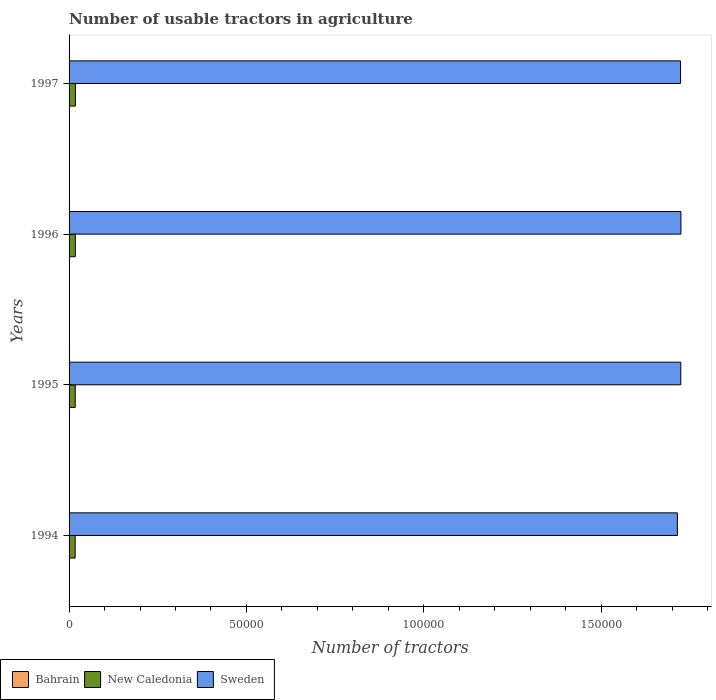How many bars are there on the 3rd tick from the top?
Make the answer very short. 3. How many bars are there on the 2nd tick from the bottom?
Your answer should be very brief. 3. In how many cases, is the number of bars for a given year not equal to the number of legend labels?
Offer a terse response. 0. Across all years, what is the maximum number of usable tractors in agriculture in Sweden?
Give a very brief answer. 1.72e+05. Across all years, what is the minimum number of usable tractors in agriculture in Sweden?
Ensure brevity in your answer.  1.72e+05. What is the difference between the number of usable tractors in agriculture in New Caledonia in 1996 and the number of usable tractors in agriculture in Sweden in 1995?
Your answer should be compact. -1.71e+05. What is the average number of usable tractors in agriculture in Sweden per year?
Provide a succinct answer. 1.72e+05. In the year 1996, what is the difference between the number of usable tractors in agriculture in Sweden and number of usable tractors in agriculture in Bahrain?
Offer a very short reply. 1.72e+05. In how many years, is the number of usable tractors in agriculture in New Caledonia greater than 110000 ?
Your answer should be very brief. 0. What is the ratio of the number of usable tractors in agriculture in New Caledonia in 1994 to that in 1997?
Offer a very short reply. 0.96. Is the number of usable tractors in agriculture in Sweden in 1995 less than that in 1996?
Provide a succinct answer. Yes. Is the difference between the number of usable tractors in agriculture in Sweden in 1995 and 1997 greater than the difference between the number of usable tractors in agriculture in Bahrain in 1995 and 1997?
Your answer should be very brief. Yes. What is the difference between the highest and the second highest number of usable tractors in agriculture in Sweden?
Give a very brief answer. 30. In how many years, is the number of usable tractors in agriculture in Bahrain greater than the average number of usable tractors in agriculture in Bahrain taken over all years?
Provide a succinct answer. 2. Is the sum of the number of usable tractors in agriculture in New Caledonia in 1994 and 1995 greater than the maximum number of usable tractors in agriculture in Bahrain across all years?
Your answer should be compact. Yes. What does the 2nd bar from the top in 1994 represents?
Keep it short and to the point. New Caledonia. What does the 2nd bar from the bottom in 1997 represents?
Your answer should be very brief. New Caledonia. Is it the case that in every year, the sum of the number of usable tractors in agriculture in Bahrain and number of usable tractors in agriculture in Sweden is greater than the number of usable tractors in agriculture in New Caledonia?
Ensure brevity in your answer.  Yes. How many bars are there?
Provide a short and direct response. 12. How many years are there in the graph?
Make the answer very short. 4. Does the graph contain any zero values?
Make the answer very short. No. Does the graph contain grids?
Your answer should be compact. No. How many legend labels are there?
Make the answer very short. 3. What is the title of the graph?
Provide a succinct answer. Number of usable tractors in agriculture. What is the label or title of the X-axis?
Keep it short and to the point. Number of tractors. What is the label or title of the Y-axis?
Offer a very short reply. Years. What is the Number of tractors in New Caledonia in 1994?
Give a very brief answer. 1710. What is the Number of tractors in Sweden in 1994?
Offer a terse response. 1.72e+05. What is the Number of tractors of Bahrain in 1995?
Offer a terse response. 14. What is the Number of tractors of New Caledonia in 1995?
Provide a short and direct response. 1735. What is the Number of tractors in Sweden in 1995?
Your answer should be very brief. 1.72e+05. What is the Number of tractors of Bahrain in 1996?
Give a very brief answer. 12. What is the Number of tractors in New Caledonia in 1996?
Offer a terse response. 1761. What is the Number of tractors of Sweden in 1996?
Offer a very short reply. 1.72e+05. What is the Number of tractors of Bahrain in 1997?
Make the answer very short. 11. What is the Number of tractors in New Caledonia in 1997?
Offer a terse response. 1787. What is the Number of tractors in Sweden in 1997?
Your answer should be compact. 1.72e+05. Across all years, what is the maximum Number of tractors in Bahrain?
Ensure brevity in your answer.  14. Across all years, what is the maximum Number of tractors in New Caledonia?
Keep it short and to the point. 1787. Across all years, what is the maximum Number of tractors of Sweden?
Ensure brevity in your answer.  1.72e+05. Across all years, what is the minimum Number of tractors in Bahrain?
Give a very brief answer. 11. Across all years, what is the minimum Number of tractors in New Caledonia?
Give a very brief answer. 1710. Across all years, what is the minimum Number of tractors in Sweden?
Offer a very short reply. 1.72e+05. What is the total Number of tractors in Bahrain in the graph?
Provide a short and direct response. 51. What is the total Number of tractors in New Caledonia in the graph?
Offer a terse response. 6993. What is the total Number of tractors of Sweden in the graph?
Provide a succinct answer. 6.89e+05. What is the difference between the Number of tractors of Bahrain in 1994 and that in 1995?
Give a very brief answer. 0. What is the difference between the Number of tractors of Sweden in 1994 and that in 1995?
Offer a terse response. -970. What is the difference between the Number of tractors of New Caledonia in 1994 and that in 1996?
Provide a succinct answer. -51. What is the difference between the Number of tractors in Sweden in 1994 and that in 1996?
Provide a short and direct response. -1000. What is the difference between the Number of tractors of Bahrain in 1994 and that in 1997?
Offer a very short reply. 3. What is the difference between the Number of tractors of New Caledonia in 1994 and that in 1997?
Your answer should be compact. -77. What is the difference between the Number of tractors of Sweden in 1994 and that in 1997?
Ensure brevity in your answer.  -900. What is the difference between the Number of tractors in Bahrain in 1995 and that in 1996?
Offer a terse response. 2. What is the difference between the Number of tractors of New Caledonia in 1995 and that in 1996?
Offer a very short reply. -26. What is the difference between the Number of tractors of Sweden in 1995 and that in 1996?
Your response must be concise. -30. What is the difference between the Number of tractors of New Caledonia in 1995 and that in 1997?
Keep it short and to the point. -52. What is the difference between the Number of tractors in Sweden in 1995 and that in 1997?
Offer a very short reply. 70. What is the difference between the Number of tractors in Bahrain in 1996 and that in 1997?
Offer a very short reply. 1. What is the difference between the Number of tractors in Bahrain in 1994 and the Number of tractors in New Caledonia in 1995?
Provide a short and direct response. -1721. What is the difference between the Number of tractors in Bahrain in 1994 and the Number of tractors in Sweden in 1995?
Keep it short and to the point. -1.72e+05. What is the difference between the Number of tractors in New Caledonia in 1994 and the Number of tractors in Sweden in 1995?
Your answer should be compact. -1.71e+05. What is the difference between the Number of tractors in Bahrain in 1994 and the Number of tractors in New Caledonia in 1996?
Your answer should be very brief. -1747. What is the difference between the Number of tractors in Bahrain in 1994 and the Number of tractors in Sweden in 1996?
Provide a succinct answer. -1.72e+05. What is the difference between the Number of tractors in New Caledonia in 1994 and the Number of tractors in Sweden in 1996?
Ensure brevity in your answer.  -1.71e+05. What is the difference between the Number of tractors in Bahrain in 1994 and the Number of tractors in New Caledonia in 1997?
Offer a very short reply. -1773. What is the difference between the Number of tractors in Bahrain in 1994 and the Number of tractors in Sweden in 1997?
Give a very brief answer. -1.72e+05. What is the difference between the Number of tractors in New Caledonia in 1994 and the Number of tractors in Sweden in 1997?
Keep it short and to the point. -1.71e+05. What is the difference between the Number of tractors in Bahrain in 1995 and the Number of tractors in New Caledonia in 1996?
Keep it short and to the point. -1747. What is the difference between the Number of tractors of Bahrain in 1995 and the Number of tractors of Sweden in 1996?
Keep it short and to the point. -1.72e+05. What is the difference between the Number of tractors of New Caledonia in 1995 and the Number of tractors of Sweden in 1996?
Your answer should be compact. -1.71e+05. What is the difference between the Number of tractors of Bahrain in 1995 and the Number of tractors of New Caledonia in 1997?
Offer a terse response. -1773. What is the difference between the Number of tractors in Bahrain in 1995 and the Number of tractors in Sweden in 1997?
Offer a terse response. -1.72e+05. What is the difference between the Number of tractors of New Caledonia in 1995 and the Number of tractors of Sweden in 1997?
Provide a succinct answer. -1.71e+05. What is the difference between the Number of tractors of Bahrain in 1996 and the Number of tractors of New Caledonia in 1997?
Your answer should be compact. -1775. What is the difference between the Number of tractors of Bahrain in 1996 and the Number of tractors of Sweden in 1997?
Give a very brief answer. -1.72e+05. What is the difference between the Number of tractors in New Caledonia in 1996 and the Number of tractors in Sweden in 1997?
Provide a short and direct response. -1.71e+05. What is the average Number of tractors in Bahrain per year?
Provide a short and direct response. 12.75. What is the average Number of tractors of New Caledonia per year?
Your answer should be compact. 1748.25. What is the average Number of tractors of Sweden per year?
Keep it short and to the point. 1.72e+05. In the year 1994, what is the difference between the Number of tractors in Bahrain and Number of tractors in New Caledonia?
Your answer should be very brief. -1696. In the year 1994, what is the difference between the Number of tractors in Bahrain and Number of tractors in Sweden?
Provide a short and direct response. -1.71e+05. In the year 1994, what is the difference between the Number of tractors of New Caledonia and Number of tractors of Sweden?
Offer a terse response. -1.70e+05. In the year 1995, what is the difference between the Number of tractors in Bahrain and Number of tractors in New Caledonia?
Provide a short and direct response. -1721. In the year 1995, what is the difference between the Number of tractors in Bahrain and Number of tractors in Sweden?
Offer a very short reply. -1.72e+05. In the year 1995, what is the difference between the Number of tractors in New Caledonia and Number of tractors in Sweden?
Make the answer very short. -1.71e+05. In the year 1996, what is the difference between the Number of tractors in Bahrain and Number of tractors in New Caledonia?
Make the answer very short. -1749. In the year 1996, what is the difference between the Number of tractors in Bahrain and Number of tractors in Sweden?
Keep it short and to the point. -1.72e+05. In the year 1996, what is the difference between the Number of tractors of New Caledonia and Number of tractors of Sweden?
Provide a succinct answer. -1.71e+05. In the year 1997, what is the difference between the Number of tractors of Bahrain and Number of tractors of New Caledonia?
Provide a succinct answer. -1776. In the year 1997, what is the difference between the Number of tractors in Bahrain and Number of tractors in Sweden?
Provide a short and direct response. -1.72e+05. In the year 1997, what is the difference between the Number of tractors in New Caledonia and Number of tractors in Sweden?
Offer a very short reply. -1.71e+05. What is the ratio of the Number of tractors in Bahrain in 1994 to that in 1995?
Offer a terse response. 1. What is the ratio of the Number of tractors of New Caledonia in 1994 to that in 1995?
Give a very brief answer. 0.99. What is the ratio of the Number of tractors of Sweden in 1994 to that in 1995?
Offer a terse response. 0.99. What is the ratio of the Number of tractors in Bahrain in 1994 to that in 1997?
Your response must be concise. 1.27. What is the ratio of the Number of tractors of New Caledonia in 1994 to that in 1997?
Offer a terse response. 0.96. What is the ratio of the Number of tractors of Bahrain in 1995 to that in 1996?
Provide a short and direct response. 1.17. What is the ratio of the Number of tractors of New Caledonia in 1995 to that in 1996?
Make the answer very short. 0.99. What is the ratio of the Number of tractors of Bahrain in 1995 to that in 1997?
Offer a very short reply. 1.27. What is the ratio of the Number of tractors of New Caledonia in 1995 to that in 1997?
Ensure brevity in your answer.  0.97. What is the ratio of the Number of tractors of New Caledonia in 1996 to that in 1997?
Make the answer very short. 0.99. What is the ratio of the Number of tractors of Sweden in 1996 to that in 1997?
Make the answer very short. 1. What is the difference between the highest and the second highest Number of tractors in Sweden?
Your answer should be very brief. 30. What is the difference between the highest and the lowest Number of tractors in Bahrain?
Offer a very short reply. 3. What is the difference between the highest and the lowest Number of tractors in Sweden?
Your answer should be very brief. 1000. 